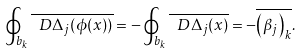Convert formula to latex. <formula><loc_0><loc_0><loc_500><loc_500>\oint _ { b _ { k } } \overline { \ D \Delta _ { j } ( \phi ( x ) ) } = - \oint _ { b _ { k } } \overline { \ D \Delta _ { j } ( x ) } = - \overline { \left ( \beta _ { j } \right ) _ { k } } .</formula> 